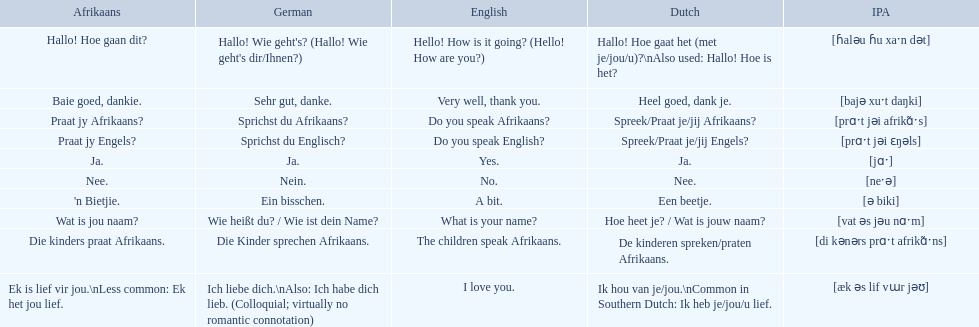In german how do you say do you speak afrikaans? Sprichst du Afrikaans?. How do you say it in afrikaans? Praat jy Afrikaans?. 